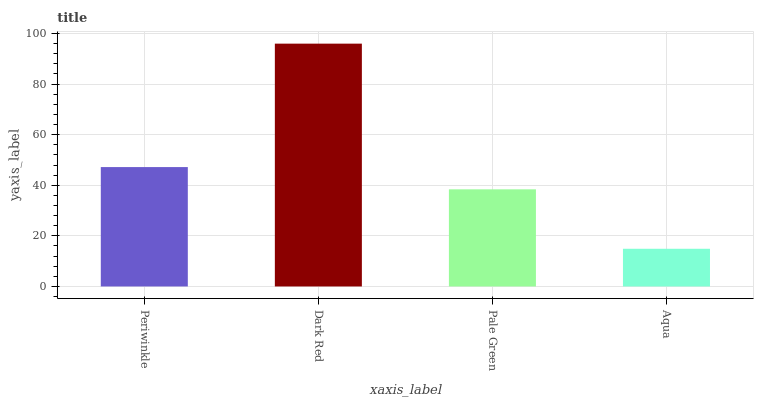Is Pale Green the minimum?
Answer yes or no. No. Is Pale Green the maximum?
Answer yes or no. No. Is Dark Red greater than Pale Green?
Answer yes or no. Yes. Is Pale Green less than Dark Red?
Answer yes or no. Yes. Is Pale Green greater than Dark Red?
Answer yes or no. No. Is Dark Red less than Pale Green?
Answer yes or no. No. Is Periwinkle the high median?
Answer yes or no. Yes. Is Pale Green the low median?
Answer yes or no. Yes. Is Dark Red the high median?
Answer yes or no. No. Is Aqua the low median?
Answer yes or no. No. 